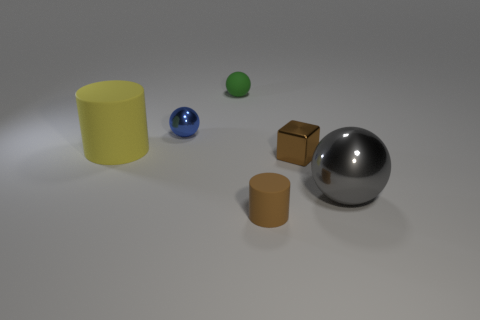How many cyan matte blocks are the same size as the green object?
Keep it short and to the point. 0. There is a matte cylinder that is the same color as the small shiny cube; what size is it?
Make the answer very short. Small. What is the color of the large object on the left side of the metallic sphere in front of the block?
Your answer should be very brief. Yellow. Are there any other tiny spheres of the same color as the small rubber ball?
Your answer should be very brief. No. There is a metallic sphere that is the same size as the yellow cylinder; what color is it?
Offer a very short reply. Gray. Is the large thing that is left of the big shiny object made of the same material as the brown cylinder?
Your response must be concise. Yes. There is a large thing that is to the right of the matte object left of the green ball; is there a tiny blue sphere in front of it?
Provide a succinct answer. No. Do the tiny rubber thing that is in front of the yellow object and the small green rubber object have the same shape?
Ensure brevity in your answer.  No. There is a tiny matte thing behind the matte cylinder in front of the big cylinder; what shape is it?
Offer a very short reply. Sphere. What is the size of the shiny sphere that is on the right side of the matte cylinder right of the rubber cylinder that is behind the big gray thing?
Your answer should be compact. Large. 